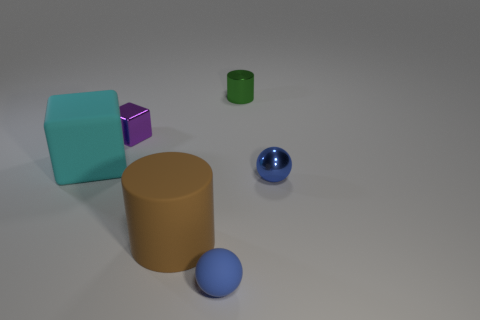Subtract all brown cylinders. How many cylinders are left? 1 Subtract 2 blocks. How many blocks are left? 0 Subtract all cylinders. How many objects are left? 4 Add 4 large brown rubber objects. How many objects exist? 10 Subtract 0 cyan cylinders. How many objects are left? 6 Subtract all green balls. Subtract all yellow cylinders. How many balls are left? 2 Subtract all yellow cylinders. How many purple blocks are left? 1 Subtract all brown cylinders. Subtract all small purple things. How many objects are left? 4 Add 3 things. How many things are left? 9 Add 4 large rubber objects. How many large rubber objects exist? 6 